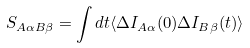Convert formula to latex. <formula><loc_0><loc_0><loc_500><loc_500>S _ { A \alpha B \beta } = \int d t \langle \Delta I _ { A \alpha } ( 0 ) \Delta I _ { B \beta } ( t ) \rangle</formula> 